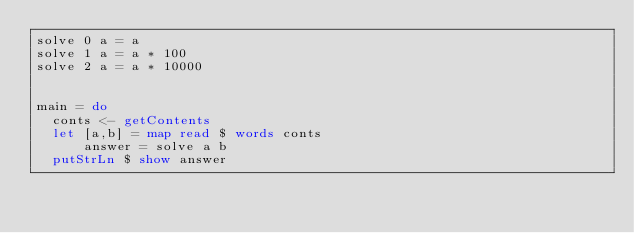<code> <loc_0><loc_0><loc_500><loc_500><_Haskell_>solve 0 a = a
solve 1 a = a * 100
solve 2 a = a * 10000


main = do
  conts <- getContents
  let [a,b] = map read $ words conts
      answer = solve a b
  putStrLn $ show answer
</code> 